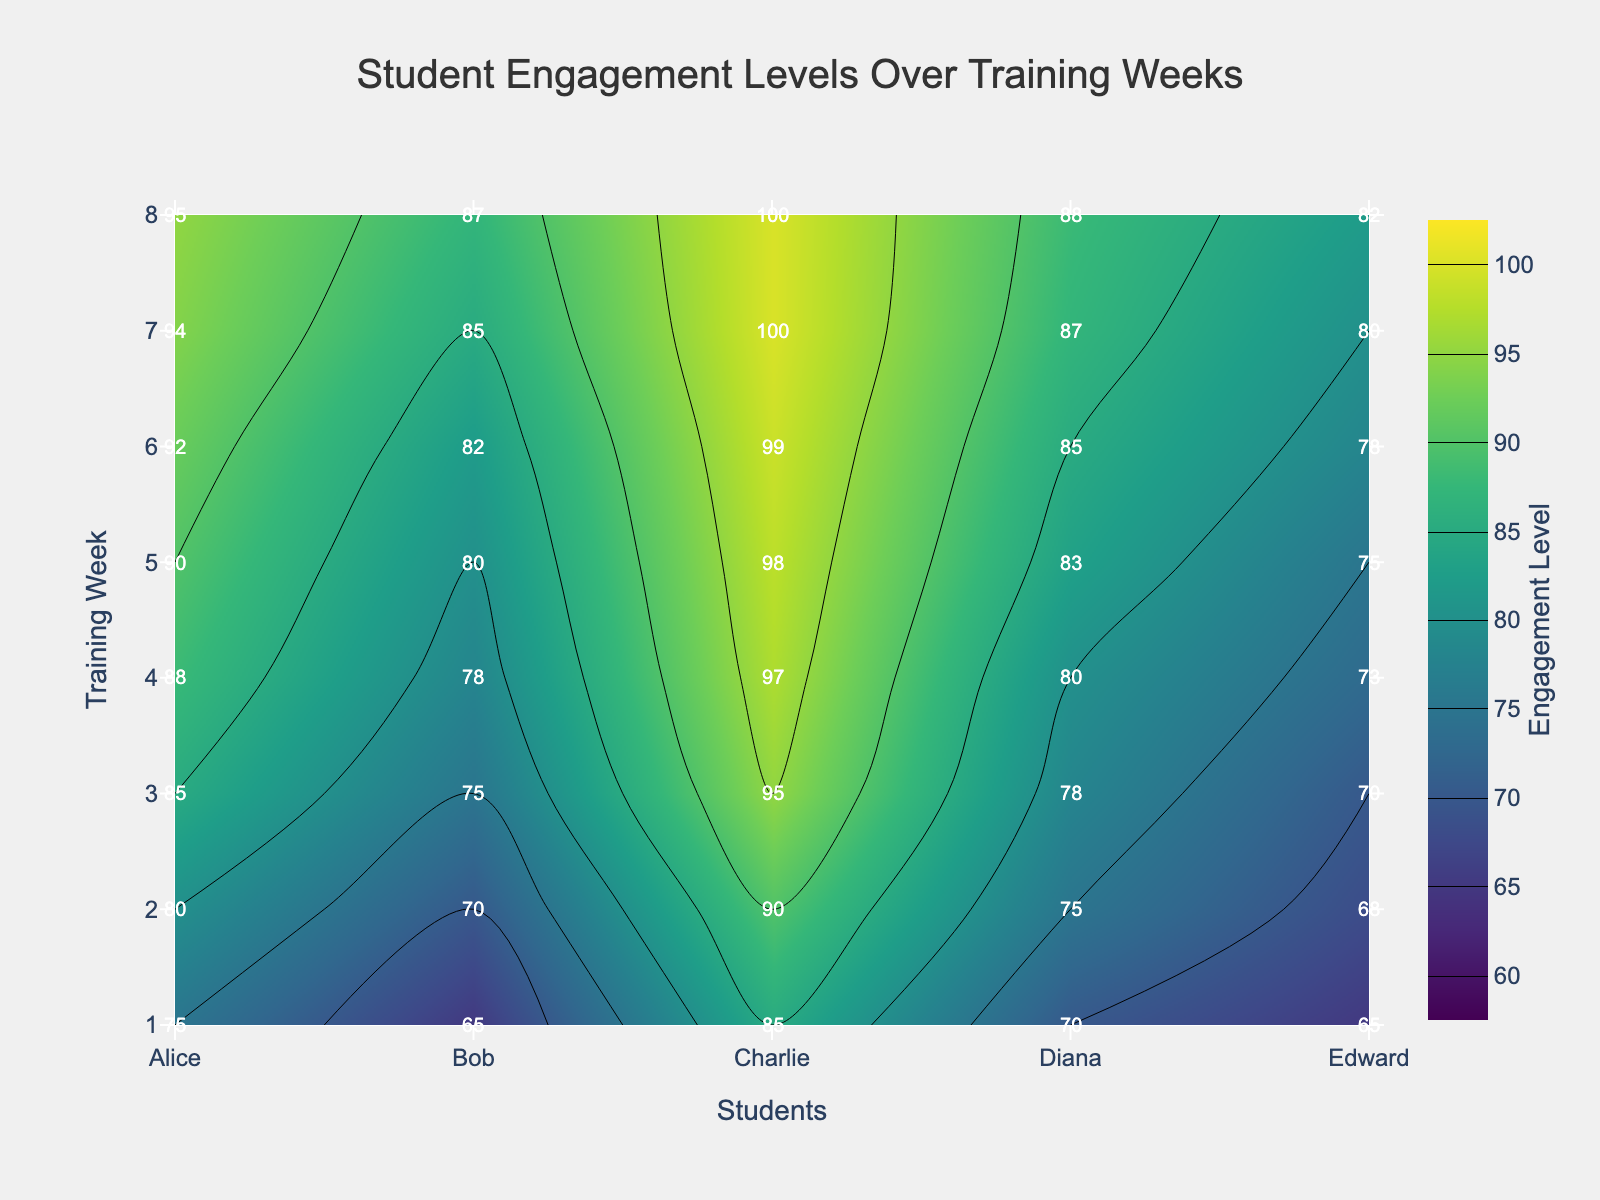What is the title of the figure? The title is generally positioned at the top of the chart and here it reads 'Student Engagement Levels Over Training Weeks'.
Answer: Student Engagement Levels Over Training Weeks Which student had the highest engagement level in the 6th week? Look at week 6 and identify the highest engagement level among the students: Alice (92), Bob (82), Charlie (99), Diana (85), Edward (78). Charlie has the highest engagement level.
Answer: Charlie How does Diana's engagement level change from week 1 to week 8? Observing Diana's engagement levels each week: Week 1 (70), Week 2 (75), Week 3 (78), Week 4 (80), Week 5 (83), Week 6 (85), Week 7 (87), Week 8 (88). Diana's engagement levels consistently increased over the weeks.
Answer: Increased What's the average engagement level of Edward over the entire program? Summing up Edward's engagement levels for 8 weeks: 65 + 68 + 70 + 73 + 75 + 78 + 80 + 82 = 591. Dividing by 8 (the number of weeks) gives an average of 591/8 = 73.875
Answer: 73.875 Which training week shows the highest average engagement level among all students? Calculate the average engagement level for each week, then compare them: 
Week 1: (75+65+85+70+65)/5 = 72 
Week 2: (80+70+90+75+68)/5 = 76.6 
Week 3: (85+75+95+78+70)/5 = 80.6 
Week 4: (88+78+97+80+73)/5 = 83.2 
Week 5: (90+80+98+83+75)/5 = 85.2 
Week 6: (92+82+99+85+78)/5 = 87.2 
Week 7: (94+85+100+87+80)/5 = 89.2 
Week 8: (95+87+100+88+82)/5 = 90.4 
Week 8 has the highest average engagement level.
Answer: Week 8 Between weeks 4 and 5, which week has a higher engagement level for Bob? Comparing Bob's engagement levels in weeks 4 and 5: Week 4 (78), Week 5 (80). Week 5 is higher than week 4.
Answer: Week 5 What range of engagement levels does the color scale cover? The contours are set between 60 and 100 in the color scale.
Answer: 60 to 100 In week 7, whose engagement level is closest to the average engagement level for that week? Calculated Week 7 average is (94+85+100+87+80)/5 = 89.2. Comparing individual levels: Alice (94), Bob (85), Charlie (100), Diana (87), Edward (80). Bob (85) is closest to 89.2.
Answer: Bob Which student shows the most consistent (least variable) engagement over the weeks? Calculating the variance for each student:
Alice: var(75, 80, 85, 88, 90, 92, 94, 95) 
Bob: var(65, 70, 75, 78, 80, 82, 85, 87) 
Charlie: var(85, 90, 95, 97, 98, 99, 100, 100) 
Diana: var(70, 75, 78, 80, 83, 85, 87, 88) 
Edward: var(65, 68, 70, 73, 75, 78, 80, 82) 
Calculating or visually assessing, Diana has the smallest fluctuations in engagement levels.
Answer: Diana 